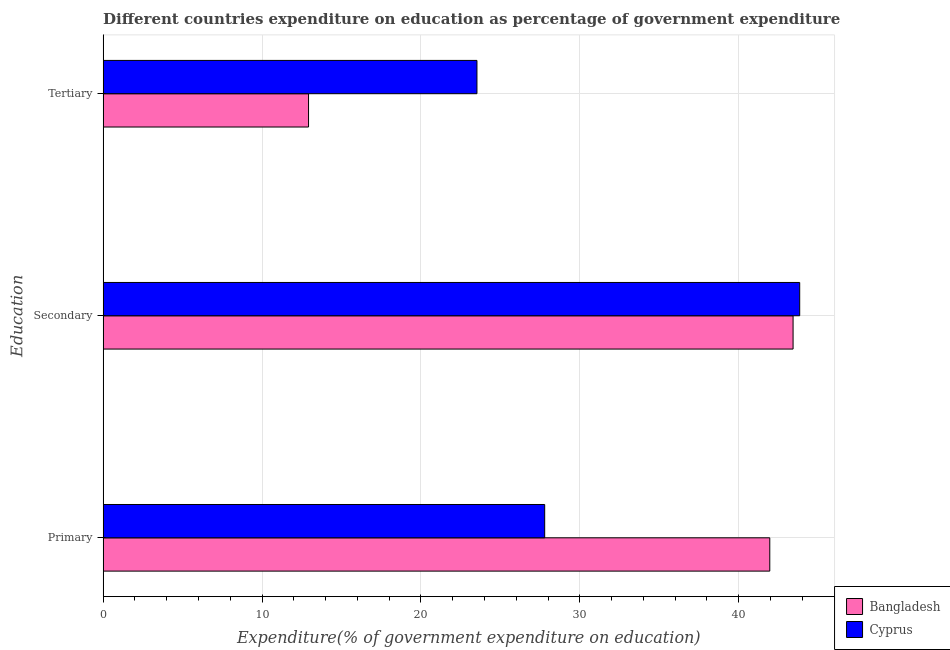How many bars are there on the 2nd tick from the top?
Make the answer very short. 2. How many bars are there on the 2nd tick from the bottom?
Your answer should be compact. 2. What is the label of the 2nd group of bars from the top?
Make the answer very short. Secondary. What is the expenditure on tertiary education in Bangladesh?
Provide a succinct answer. 12.93. Across all countries, what is the maximum expenditure on secondary education?
Ensure brevity in your answer.  43.84. Across all countries, what is the minimum expenditure on secondary education?
Provide a succinct answer. 43.42. In which country was the expenditure on secondary education maximum?
Your answer should be compact. Cyprus. In which country was the expenditure on tertiary education minimum?
Your answer should be compact. Bangladesh. What is the total expenditure on tertiary education in the graph?
Offer a very short reply. 36.45. What is the difference between the expenditure on tertiary education in Bangladesh and that in Cyprus?
Provide a succinct answer. -10.6. What is the difference between the expenditure on secondary education in Bangladesh and the expenditure on primary education in Cyprus?
Keep it short and to the point. 15.63. What is the average expenditure on primary education per country?
Your answer should be compact. 34.87. What is the difference between the expenditure on primary education and expenditure on secondary education in Bangladesh?
Keep it short and to the point. -1.47. In how many countries, is the expenditure on primary education greater than 6 %?
Your answer should be compact. 2. What is the ratio of the expenditure on secondary education in Cyprus to that in Bangladesh?
Offer a very short reply. 1.01. What is the difference between the highest and the second highest expenditure on tertiary education?
Keep it short and to the point. 10.6. What is the difference between the highest and the lowest expenditure on secondary education?
Your response must be concise. 0.42. In how many countries, is the expenditure on tertiary education greater than the average expenditure on tertiary education taken over all countries?
Your answer should be compact. 1. What does the 1st bar from the top in Tertiary represents?
Your response must be concise. Cyprus. What does the 1st bar from the bottom in Secondary represents?
Provide a short and direct response. Bangladesh. Are all the bars in the graph horizontal?
Make the answer very short. Yes. How many countries are there in the graph?
Ensure brevity in your answer.  2. Where does the legend appear in the graph?
Ensure brevity in your answer.  Bottom right. How many legend labels are there?
Your answer should be very brief. 2. How are the legend labels stacked?
Offer a very short reply. Vertical. What is the title of the graph?
Provide a short and direct response. Different countries expenditure on education as percentage of government expenditure. Does "High income: nonOECD" appear as one of the legend labels in the graph?
Give a very brief answer. No. What is the label or title of the X-axis?
Make the answer very short. Expenditure(% of government expenditure on education). What is the label or title of the Y-axis?
Offer a terse response. Education. What is the Expenditure(% of government expenditure on education) of Bangladesh in Primary?
Your answer should be very brief. 41.96. What is the Expenditure(% of government expenditure on education) of Cyprus in Primary?
Offer a terse response. 27.79. What is the Expenditure(% of government expenditure on education) in Bangladesh in Secondary?
Offer a very short reply. 43.42. What is the Expenditure(% of government expenditure on education) of Cyprus in Secondary?
Offer a very short reply. 43.84. What is the Expenditure(% of government expenditure on education) in Bangladesh in Tertiary?
Provide a succinct answer. 12.93. What is the Expenditure(% of government expenditure on education) in Cyprus in Tertiary?
Give a very brief answer. 23.53. Across all Education, what is the maximum Expenditure(% of government expenditure on education) in Bangladesh?
Your answer should be very brief. 43.42. Across all Education, what is the maximum Expenditure(% of government expenditure on education) of Cyprus?
Your answer should be very brief. 43.84. Across all Education, what is the minimum Expenditure(% of government expenditure on education) of Bangladesh?
Your response must be concise. 12.93. Across all Education, what is the minimum Expenditure(% of government expenditure on education) in Cyprus?
Provide a short and direct response. 23.53. What is the total Expenditure(% of government expenditure on education) of Bangladesh in the graph?
Keep it short and to the point. 98.31. What is the total Expenditure(% of government expenditure on education) in Cyprus in the graph?
Offer a very short reply. 95.16. What is the difference between the Expenditure(% of government expenditure on education) in Bangladesh in Primary and that in Secondary?
Your answer should be compact. -1.47. What is the difference between the Expenditure(% of government expenditure on education) in Cyprus in Primary and that in Secondary?
Offer a terse response. -16.05. What is the difference between the Expenditure(% of government expenditure on education) of Bangladesh in Primary and that in Tertiary?
Ensure brevity in your answer.  29.03. What is the difference between the Expenditure(% of government expenditure on education) of Cyprus in Primary and that in Tertiary?
Your answer should be compact. 4.26. What is the difference between the Expenditure(% of government expenditure on education) of Bangladesh in Secondary and that in Tertiary?
Provide a short and direct response. 30.49. What is the difference between the Expenditure(% of government expenditure on education) of Cyprus in Secondary and that in Tertiary?
Make the answer very short. 20.31. What is the difference between the Expenditure(% of government expenditure on education) in Bangladesh in Primary and the Expenditure(% of government expenditure on education) in Cyprus in Secondary?
Ensure brevity in your answer.  -1.88. What is the difference between the Expenditure(% of government expenditure on education) in Bangladesh in Primary and the Expenditure(% of government expenditure on education) in Cyprus in Tertiary?
Offer a very short reply. 18.43. What is the difference between the Expenditure(% of government expenditure on education) of Bangladesh in Secondary and the Expenditure(% of government expenditure on education) of Cyprus in Tertiary?
Your answer should be very brief. 19.9. What is the average Expenditure(% of government expenditure on education) in Bangladesh per Education?
Your response must be concise. 32.77. What is the average Expenditure(% of government expenditure on education) of Cyprus per Education?
Provide a succinct answer. 31.72. What is the difference between the Expenditure(% of government expenditure on education) in Bangladesh and Expenditure(% of government expenditure on education) in Cyprus in Primary?
Give a very brief answer. 14.17. What is the difference between the Expenditure(% of government expenditure on education) in Bangladesh and Expenditure(% of government expenditure on education) in Cyprus in Secondary?
Your answer should be very brief. -0.42. What is the difference between the Expenditure(% of government expenditure on education) of Bangladesh and Expenditure(% of government expenditure on education) of Cyprus in Tertiary?
Give a very brief answer. -10.6. What is the ratio of the Expenditure(% of government expenditure on education) of Bangladesh in Primary to that in Secondary?
Provide a succinct answer. 0.97. What is the ratio of the Expenditure(% of government expenditure on education) of Cyprus in Primary to that in Secondary?
Keep it short and to the point. 0.63. What is the ratio of the Expenditure(% of government expenditure on education) of Bangladesh in Primary to that in Tertiary?
Offer a terse response. 3.25. What is the ratio of the Expenditure(% of government expenditure on education) in Cyprus in Primary to that in Tertiary?
Offer a very short reply. 1.18. What is the ratio of the Expenditure(% of government expenditure on education) in Bangladesh in Secondary to that in Tertiary?
Offer a very short reply. 3.36. What is the ratio of the Expenditure(% of government expenditure on education) of Cyprus in Secondary to that in Tertiary?
Your answer should be very brief. 1.86. What is the difference between the highest and the second highest Expenditure(% of government expenditure on education) of Bangladesh?
Keep it short and to the point. 1.47. What is the difference between the highest and the second highest Expenditure(% of government expenditure on education) in Cyprus?
Make the answer very short. 16.05. What is the difference between the highest and the lowest Expenditure(% of government expenditure on education) in Bangladesh?
Keep it short and to the point. 30.49. What is the difference between the highest and the lowest Expenditure(% of government expenditure on education) in Cyprus?
Your response must be concise. 20.31. 